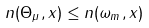Convert formula to latex. <formula><loc_0><loc_0><loc_500><loc_500>n ( \Theta _ { \mu } , x ) \leq n ( \omega _ { m } , x )</formula> 